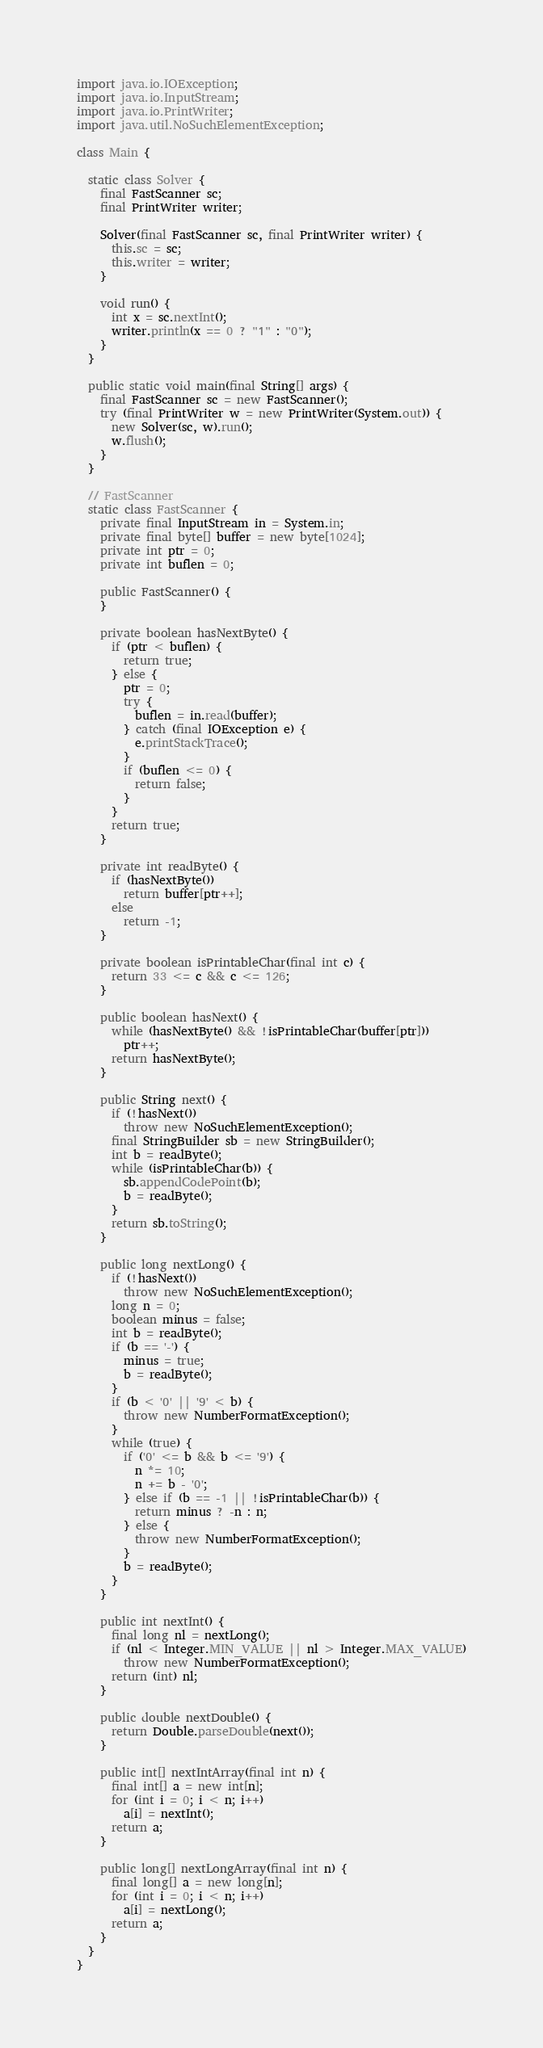Convert code to text. <code><loc_0><loc_0><loc_500><loc_500><_Java_>import java.io.IOException;
import java.io.InputStream;
import java.io.PrintWriter;
import java.util.NoSuchElementException;

class Main {

  static class Solver {
    final FastScanner sc;
    final PrintWriter writer;

    Solver(final FastScanner sc, final PrintWriter writer) {
      this.sc = sc;
      this.writer = writer;
    }

    void run() {
      int x = sc.nextInt();
      writer.println(x == 0 ? "1" : "0");
    }
  }

  public static void main(final String[] args) {
    final FastScanner sc = new FastScanner();
    try (final PrintWriter w = new PrintWriter(System.out)) {
      new Solver(sc, w).run();
      w.flush();
    }
  }

  // FastScanner
  static class FastScanner {
    private final InputStream in = System.in;
    private final byte[] buffer = new byte[1024];
    private int ptr = 0;
    private int buflen = 0;

    public FastScanner() {
    }

    private boolean hasNextByte() {
      if (ptr < buflen) {
        return true;
      } else {
        ptr = 0;
        try {
          buflen = in.read(buffer);
        } catch (final IOException e) {
          e.printStackTrace();
        }
        if (buflen <= 0) {
          return false;
        }
      }
      return true;
    }

    private int readByte() {
      if (hasNextByte())
        return buffer[ptr++];
      else
        return -1;
    }

    private boolean isPrintableChar(final int c) {
      return 33 <= c && c <= 126;
    }

    public boolean hasNext() {
      while (hasNextByte() && !isPrintableChar(buffer[ptr]))
        ptr++;
      return hasNextByte();
    }

    public String next() {
      if (!hasNext())
        throw new NoSuchElementException();
      final StringBuilder sb = new StringBuilder();
      int b = readByte();
      while (isPrintableChar(b)) {
        sb.appendCodePoint(b);
        b = readByte();
      }
      return sb.toString();
    }

    public long nextLong() {
      if (!hasNext())
        throw new NoSuchElementException();
      long n = 0;
      boolean minus = false;
      int b = readByte();
      if (b == '-') {
        minus = true;
        b = readByte();
      }
      if (b < '0' || '9' < b) {
        throw new NumberFormatException();
      }
      while (true) {
        if ('0' <= b && b <= '9') {
          n *= 10;
          n += b - '0';
        } else if (b == -1 || !isPrintableChar(b)) {
          return minus ? -n : n;
        } else {
          throw new NumberFormatException();
        }
        b = readByte();
      }
    }

    public int nextInt() {
      final long nl = nextLong();
      if (nl < Integer.MIN_VALUE || nl > Integer.MAX_VALUE)
        throw new NumberFormatException();
      return (int) nl;
    }

    public double nextDouble() {
      return Double.parseDouble(next());
    }

    public int[] nextIntArray(final int n) {
      final int[] a = new int[n];
      for (int i = 0; i < n; i++)
        a[i] = nextInt();
      return a;
    }

    public long[] nextLongArray(final int n) {
      final long[] a = new long[n];
      for (int i = 0; i < n; i++)
        a[i] = nextLong();
      return a;
    }
  }
}
</code> 